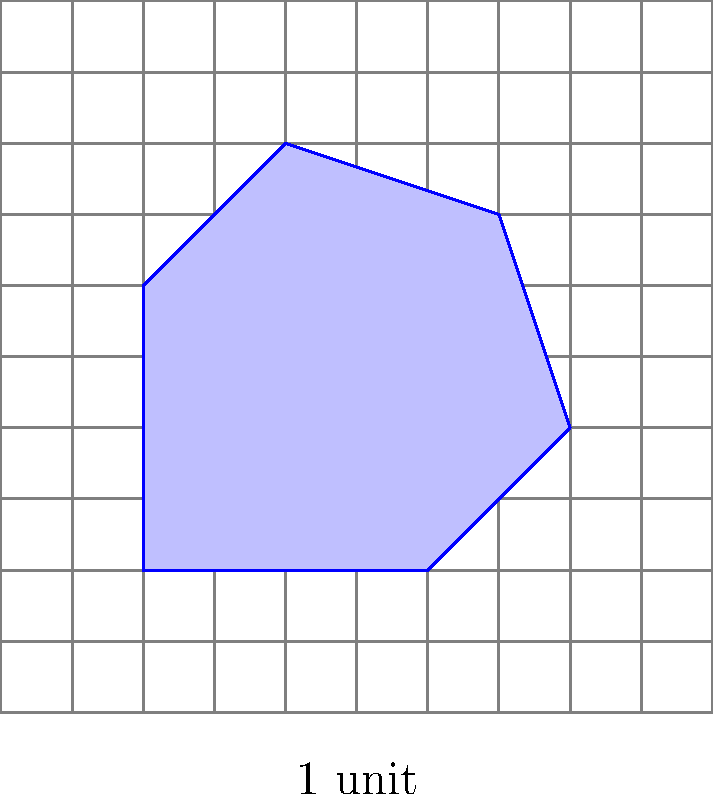As a full-stack developer working on a feature that calculates areas of custom shapes drawn by users, you need to implement a grid-based area calculation method. Given the irregular shape shown in the grid above, where each square represents 1 unit^2, estimate its area to the nearest whole number. To estimate the area of the irregular shape using the grid system, we'll follow these steps:

1. Count the number of whole squares inside the shape.
2. Estimate the fractional parts of squares that are partially covered.
3. Sum up the whole and partial square counts.

Step-by-step calculation:

1. Whole squares: There are approximately 18 whole squares fully inside the shape.

2. Partial squares (estimating to the nearest 0.25):
   - Bottom row: 0.5 + 0.75 = 1.25
   - Top row: 0.5 + 0.5 = 1
   - Left side: 0.5 + 0.25 = 0.75
   - Right side: 0.5 + 0.75 + 0.25 = 1.5

3. Sum of partial squares: 1.25 + 1 + 0.75 + 1.5 = 4.5

4. Total estimated area: 18 (whole squares) + 4.5 (partial squares) = 22.5 square units

5. Rounding to the nearest whole number: 23 square units

As a developer, you would implement this logic in your code to calculate the area based on the grid coordinates of the shape's outline.
Answer: 23 square units 